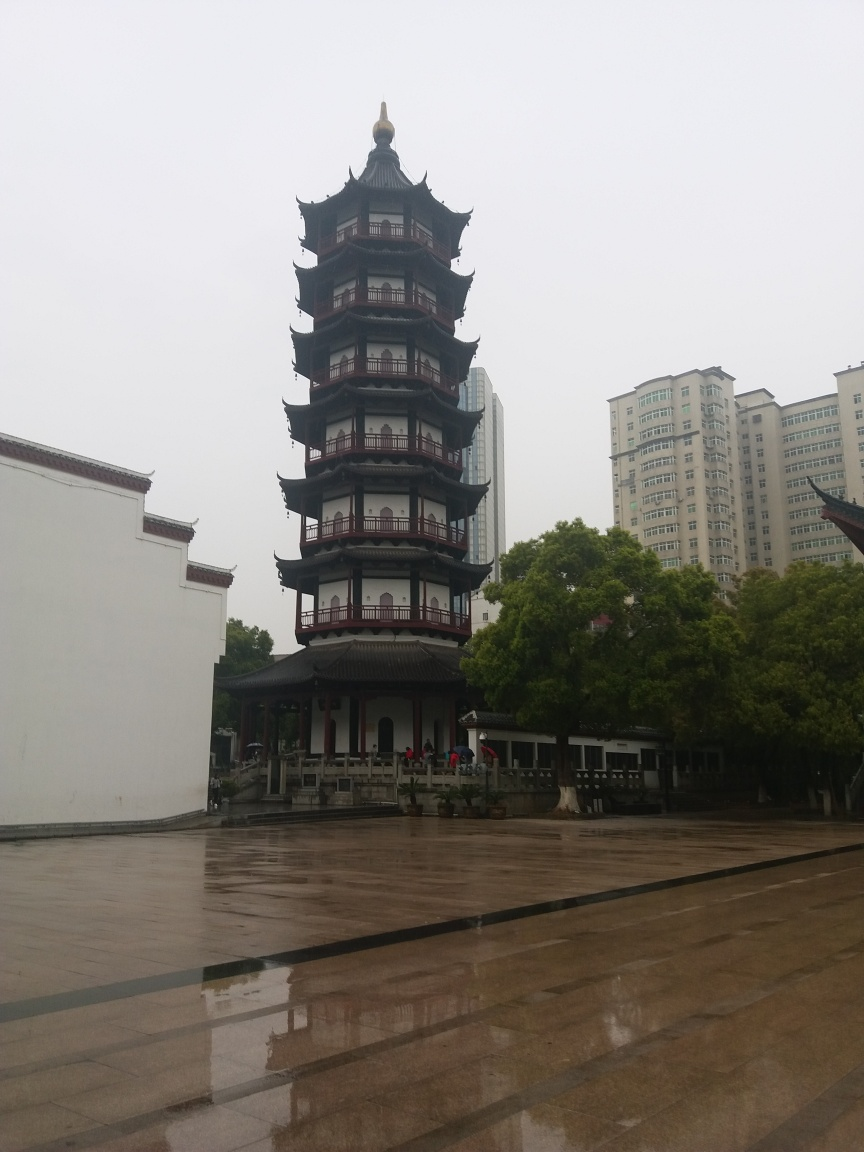What can you infer about the location of the pagoda? The pagoda is situated in an urban environment, surrounded by modern buildings that suggest a city context. The juxtaposition of traditional and modern architectural elements hints at a place where historical preservation is valued amidst urban development. It's likely located in a public or culturally significant space, as there are people visiting the site. 